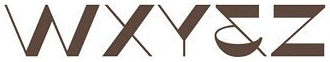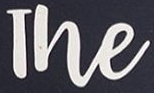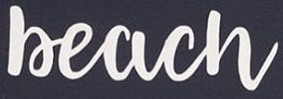What words can you see in these images in sequence, separated by a semicolon? WXY&Z; The; Beach 